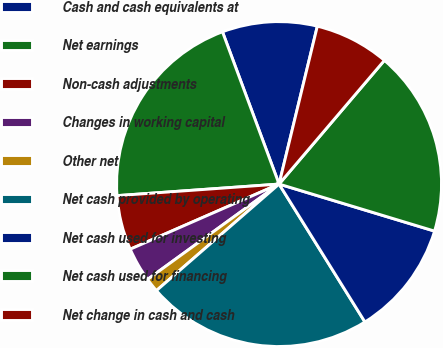Convert chart. <chart><loc_0><loc_0><loc_500><loc_500><pie_chart><fcel>Cash and cash equivalents at<fcel>Net earnings<fcel>Non-cash adjustments<fcel>Changes in working capital<fcel>Other net<fcel>Net cash provided by operating<fcel>Net cash used for investing<fcel>Net cash used for financing<fcel>Net change in cash and cash<nl><fcel>9.45%<fcel>20.47%<fcel>5.43%<fcel>3.42%<fcel>1.4%<fcel>22.48%<fcel>11.46%<fcel>18.45%<fcel>7.44%<nl></chart> 